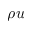Convert formula to latex. <formula><loc_0><loc_0><loc_500><loc_500>\rho u</formula> 